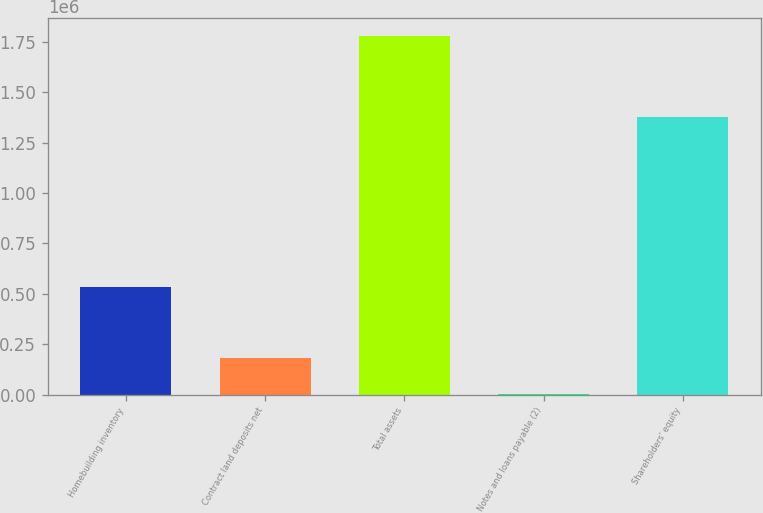Convert chart to OTSL. <chart><loc_0><loc_0><loc_500><loc_500><bar_chart><fcel>Homebuilding inventory<fcel>Contract land deposits net<fcel>Total assets<fcel>Notes and loans payable (2)<fcel>Shareholders' equity<nl><fcel>533150<fcel>179400<fcel>1.77948e+06<fcel>1613<fcel>1.3748e+06<nl></chart> 